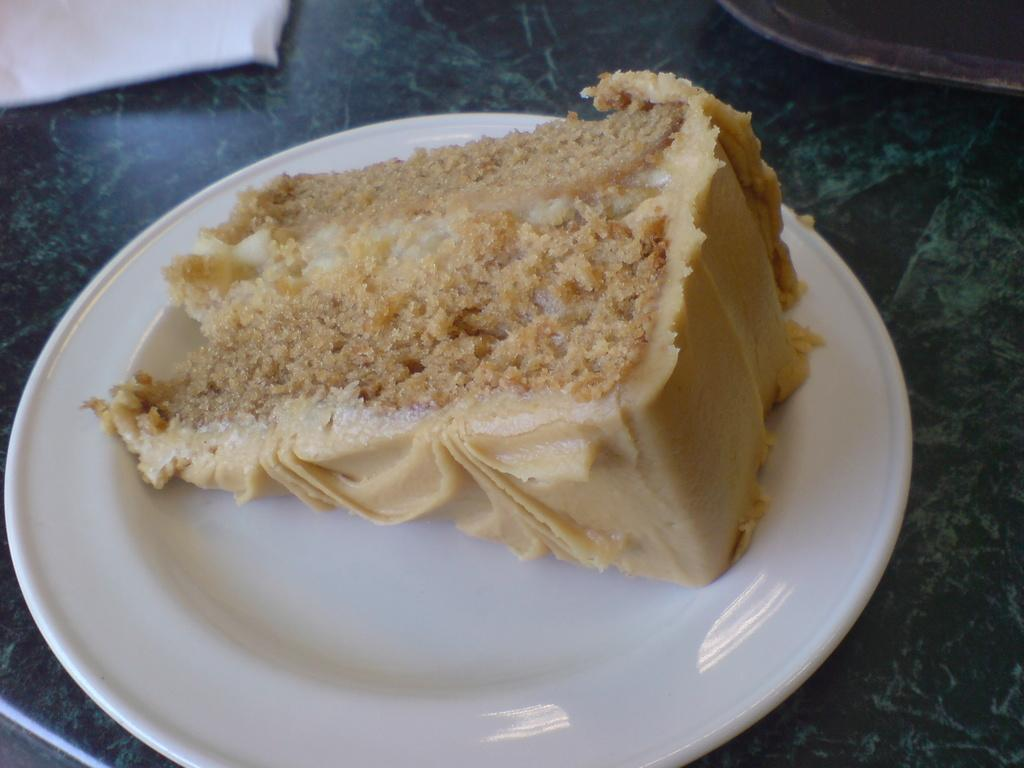What is on the plate in the image? There is a piece of cake on a plate in the image. What color is the plate? The plate is white. What type of surface is the plate resting on? The plate is on a stone surface. Can you describe the objects at the top of the image? Unfortunately, the provided facts do not give any information about the objects at the top of the image. What type of wool is used to make the pump in the image? There is no pump or wool present in the image. 